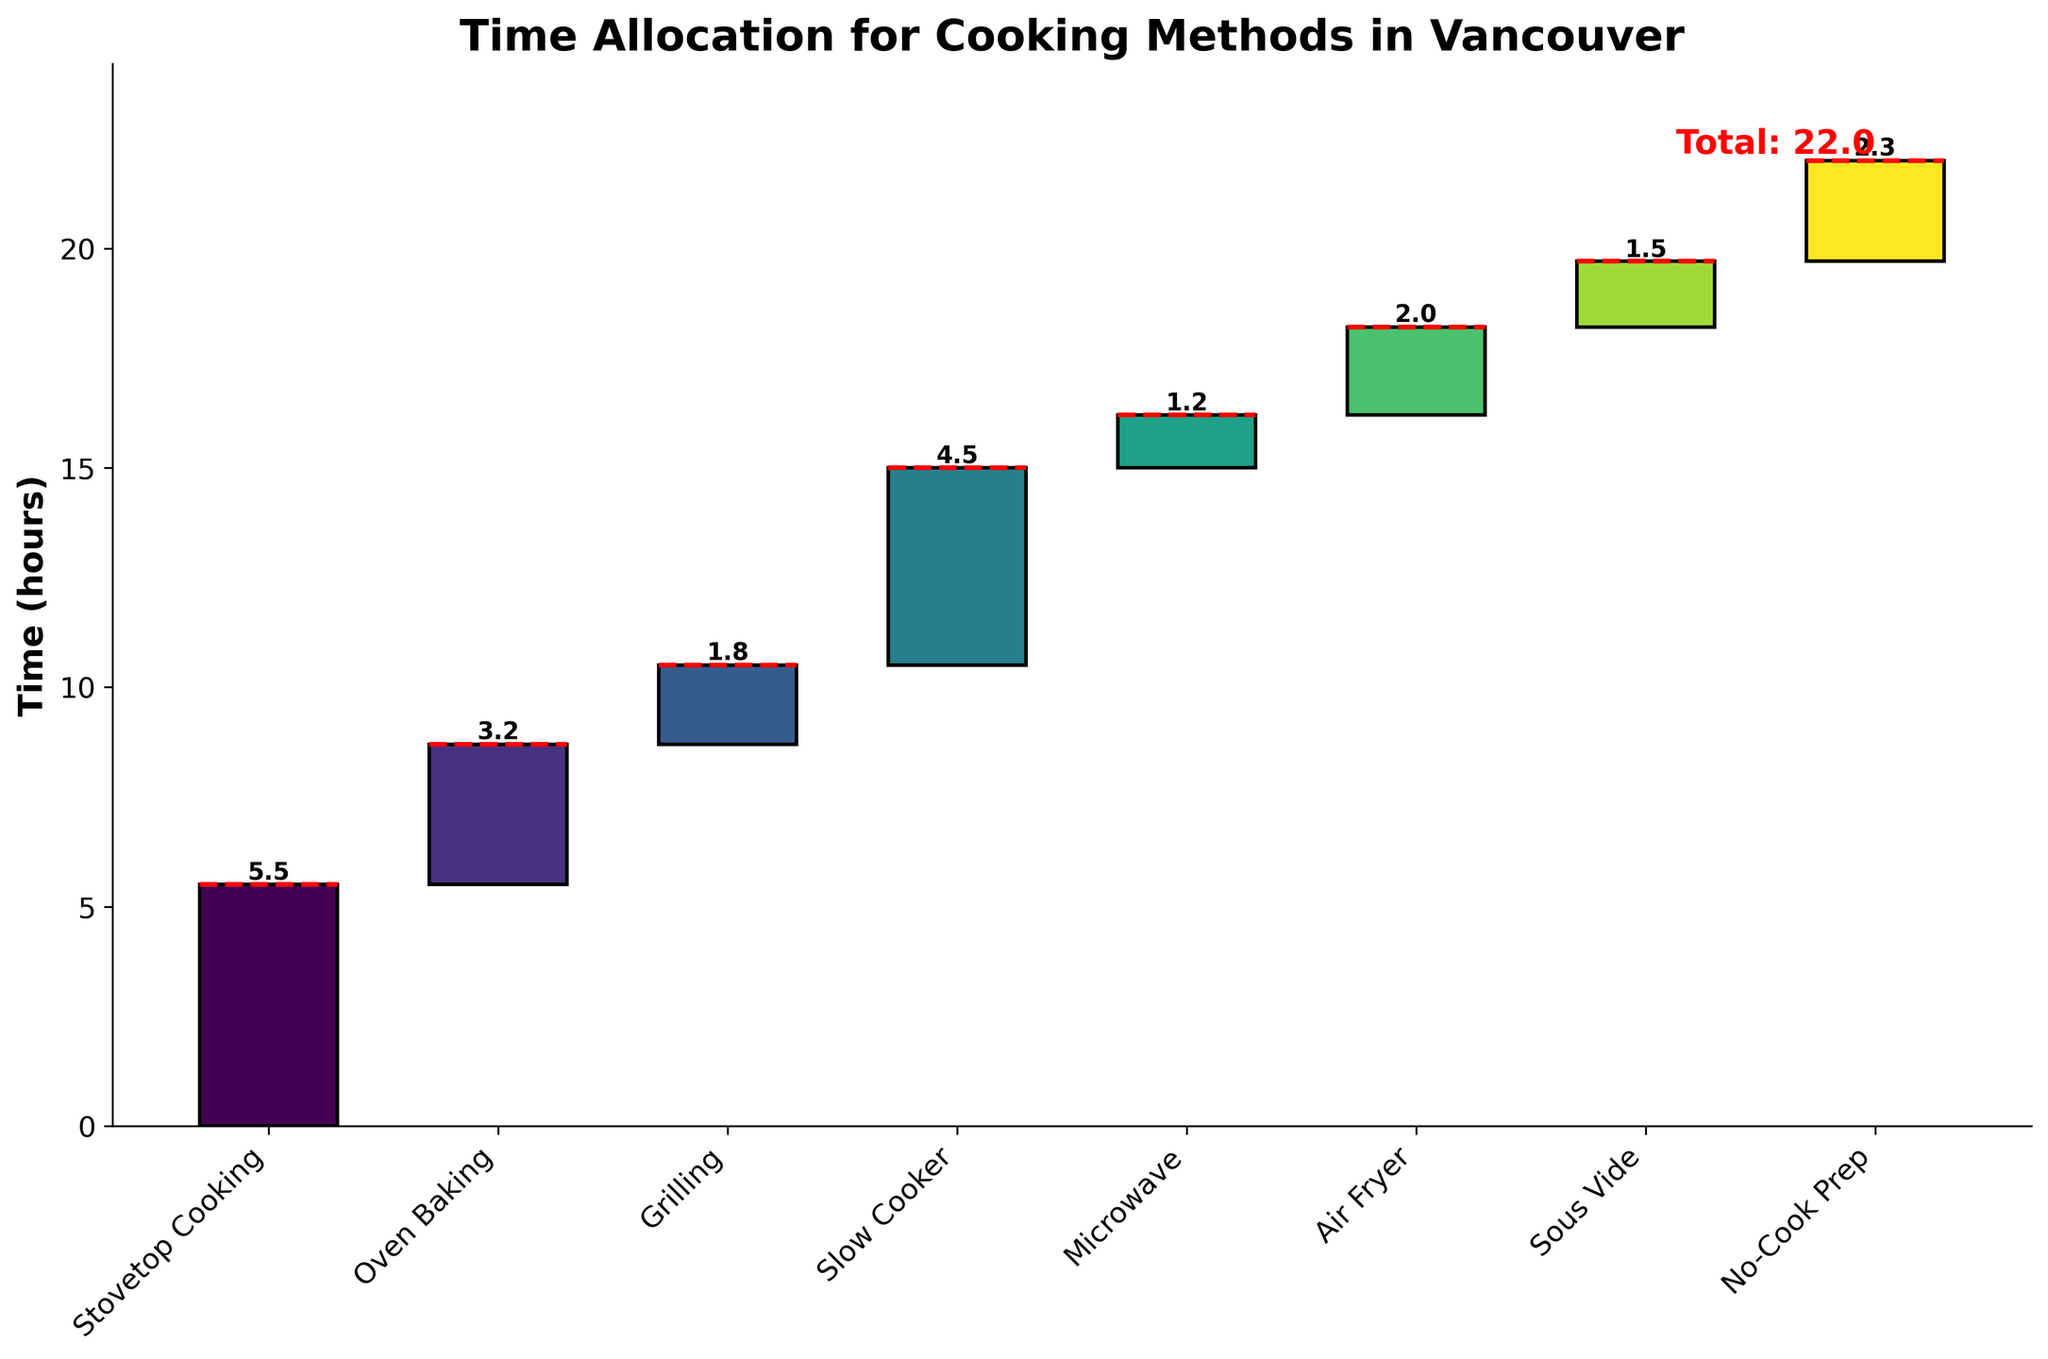How many categories are represented in the chart? There are labels for each category along the x-axis of the chart. By counting these labels, you find 8 categories from "Stovetop Cooking" to "No-Cook Prep".
Answer: 8 What is the total time spent on all cooking methods? The total time is explicitly shown on the y-axis and marked by a red horizontal line at the top of the chart: "Total: 22.0".
Answer: 22.0 hours Which cooking method has the highest allocated time? By looking at the top of each colored bar segment, the one with the tallest segment will indicate the highest time value. "Stovetop Cooking" has the highest bar segment showing a value of 5.5 hours.
Answer: Stovetop Cooking What is the difference in cooking time between the oven baking and the grilling methods? From the chart, "Oven Baking" is 3.2 hours and "Grilling" is 1.8 hours. The difference is 3.2 - 1.8.
Answer: 1.4 hours What two methods contribute equally to the cumulative time? Observing the values on the bars, both "Air Fryer" (2.0 hrs) and "Sous Vide" (1.5 hrs) show cumulative additions. But "No-Cook Prep" (2.3 hrs) seems to stand along. So, "Air Fryer" and "Sous Vide" do not contribute exactly the same, but could be assumed similarly.
Answer: None exactly equal Which cooking method contributes the least amount of time? By examining the smallest bar segment in the chart, "Microwave" with 1.2 hours is the least.
Answer: Microwave How many cooking methods each take more than 2 hours? Looking at the bar segments, "Stovetop Cooking", "Slow Cooker", "Air Fryer", and "No-Cook Prep" all exceed 2 hours.
Answer: 4 What is the combined time spent on "Grilling" and "Microwave" methods? The respective times are 1.8 hours for "Grilling" and 1.2 hours for "Microwave". Adding these values gives 1.8 + 1.2.
Answer: 3.0 hours What percentage of total time is allocated to "Stovetop Cooking"? The "Stovetop Cooking" time is 5.5 hours. The percentage is (5.5 / 22.0) * 100.0.
Answer: 25% Is "Slow Cooker" cooking time greater than the combined time of "Air Fryer" and "Sous Vide"? "Slow Cooker" time is 4.5 hours. Combining "Air Fryer" (2.0 hours) and "Sous Vide" (1.5 hours) gives 2.0 + 1.5 = 3.5 hours. Since 4.5 > 3.5, yes it is greater.
Answer: Yes 